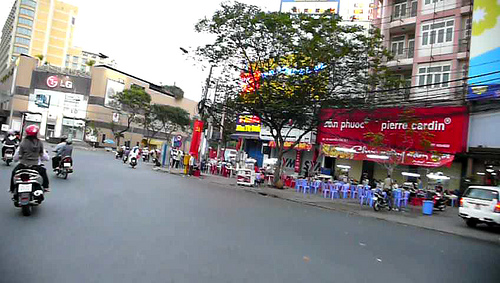On which side is the chair? The chair is located on the right side of the image. 